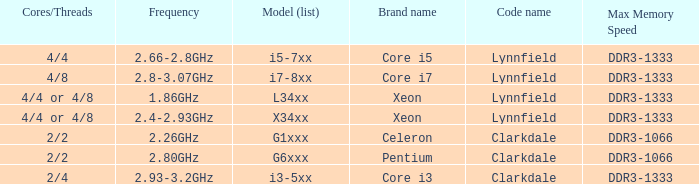List the number of cores for ddr3-1333 with frequencies between 2.66-2.8ghz. 4/4. 